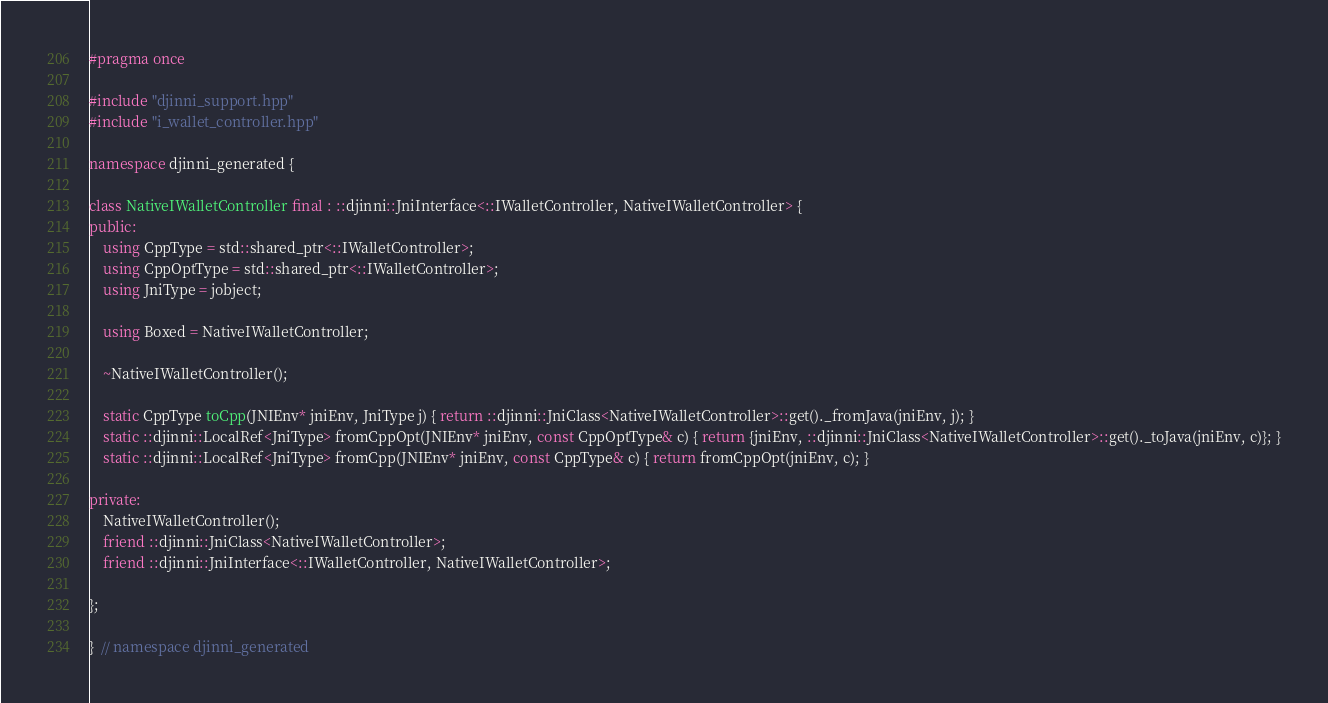<code> <loc_0><loc_0><loc_500><loc_500><_C++_>#pragma once

#include "djinni_support.hpp"
#include "i_wallet_controller.hpp"

namespace djinni_generated {

class NativeIWalletController final : ::djinni::JniInterface<::IWalletController, NativeIWalletController> {
public:
    using CppType = std::shared_ptr<::IWalletController>;
    using CppOptType = std::shared_ptr<::IWalletController>;
    using JniType = jobject;

    using Boxed = NativeIWalletController;

    ~NativeIWalletController();

    static CppType toCpp(JNIEnv* jniEnv, JniType j) { return ::djinni::JniClass<NativeIWalletController>::get()._fromJava(jniEnv, j); }
    static ::djinni::LocalRef<JniType> fromCppOpt(JNIEnv* jniEnv, const CppOptType& c) { return {jniEnv, ::djinni::JniClass<NativeIWalletController>::get()._toJava(jniEnv, c)}; }
    static ::djinni::LocalRef<JniType> fromCpp(JNIEnv* jniEnv, const CppType& c) { return fromCppOpt(jniEnv, c); }

private:
    NativeIWalletController();
    friend ::djinni::JniClass<NativeIWalletController>;
    friend ::djinni::JniInterface<::IWalletController, NativeIWalletController>;

};

}  // namespace djinni_generated
</code> 